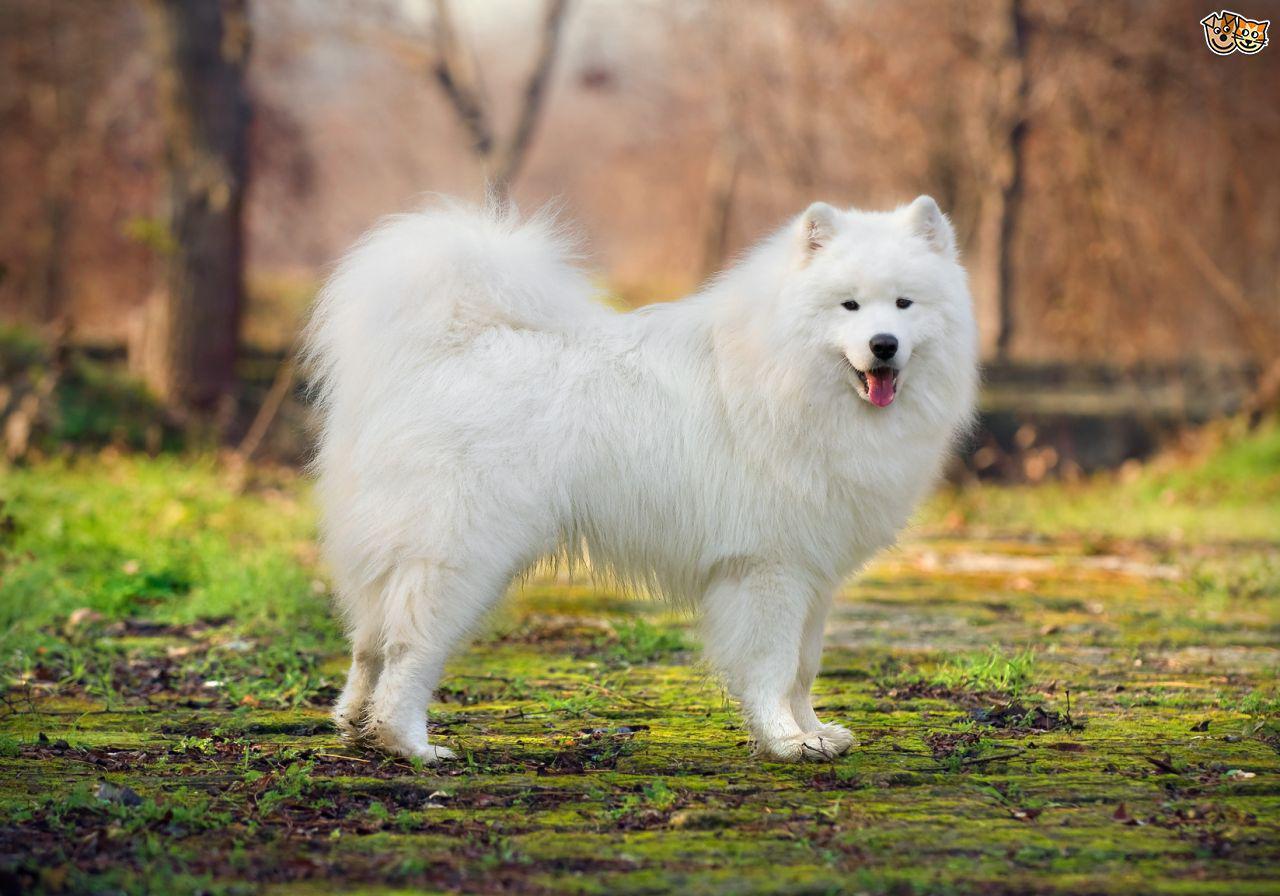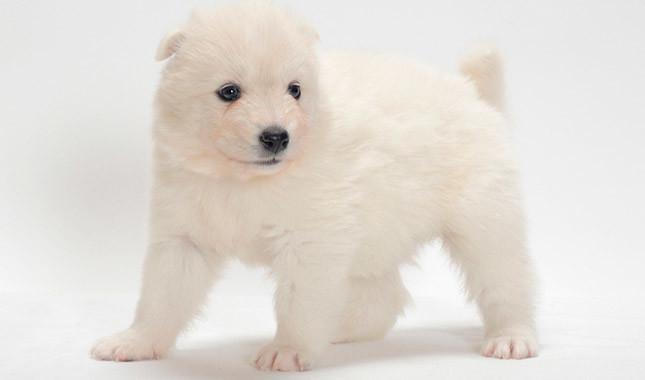The first image is the image on the left, the second image is the image on the right. Analyze the images presented: Is the assertion "Atleast one picture of a single dog posing on grass" valid? Answer yes or no. Yes. The first image is the image on the left, the second image is the image on the right. Analyze the images presented: Is the assertion "At least one of the images features a puppy without an adult." valid? Answer yes or no. Yes. 